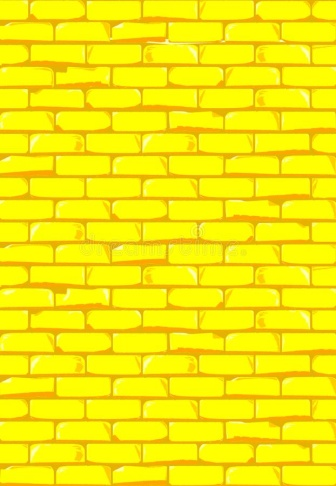Describe the following image. The image depicts a vibrant yellow brick wall, meticulously assembled with bricks lined in a staggered fashion. The stark white mortar complements the vivid yellow of the bricks, creating a striking visual contrast. This close-up view not only showcases the uniformity and precision in the brickwork but also highlights the wall's immaculate condition, free from any signs of deterioration or wear. Such walls could be symbolic of boundaries, security, or even tradition in architectural style, depending on their context within an environment. 